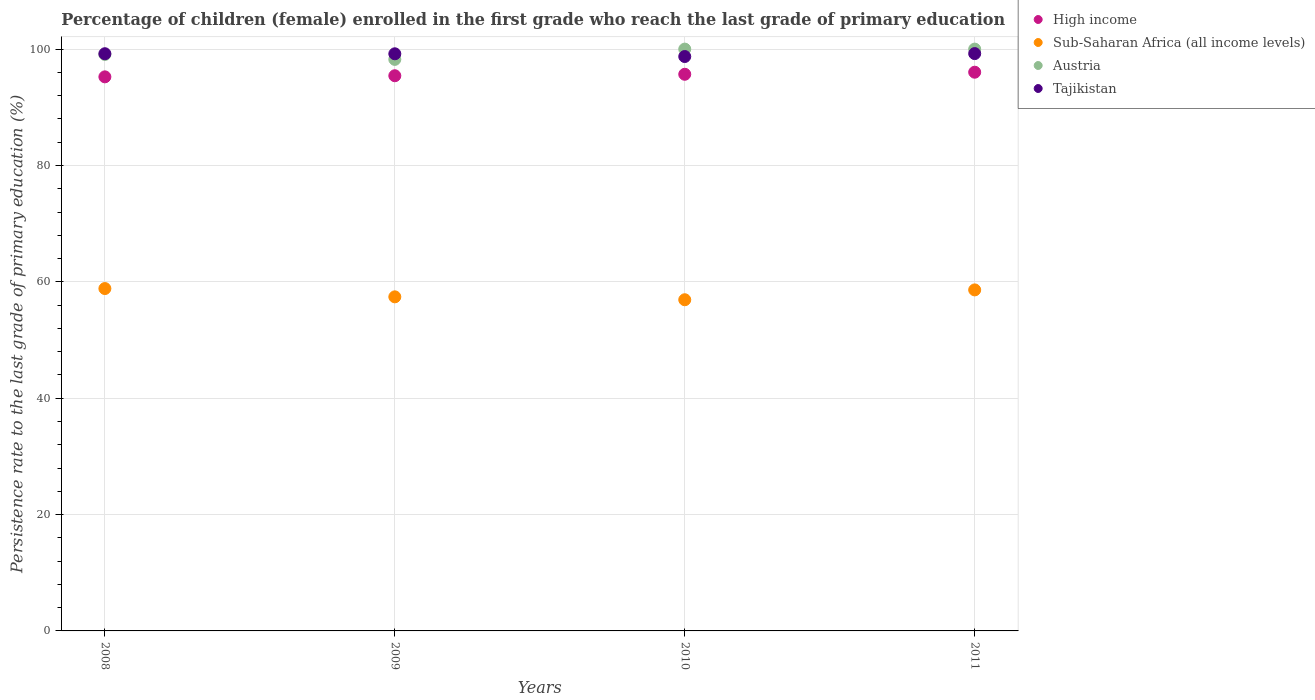What is the persistence rate of children in Tajikistan in 2010?
Make the answer very short. 98.72. Across all years, what is the maximum persistence rate of children in Austria?
Offer a very short reply. 100. Across all years, what is the minimum persistence rate of children in Austria?
Offer a terse response. 98.23. In which year was the persistence rate of children in Tajikistan maximum?
Your answer should be compact. 2011. In which year was the persistence rate of children in Tajikistan minimum?
Ensure brevity in your answer.  2010. What is the total persistence rate of children in High income in the graph?
Make the answer very short. 382.36. What is the difference between the persistence rate of children in High income in 2009 and that in 2011?
Keep it short and to the point. -0.61. What is the difference between the persistence rate of children in High income in 2009 and the persistence rate of children in Tajikistan in 2008?
Give a very brief answer. -3.78. What is the average persistence rate of children in Austria per year?
Ensure brevity in your answer.  99.33. In the year 2008, what is the difference between the persistence rate of children in Sub-Saharan Africa (all income levels) and persistence rate of children in High income?
Give a very brief answer. -36.39. In how many years, is the persistence rate of children in Sub-Saharan Africa (all income levels) greater than 52 %?
Ensure brevity in your answer.  4. What is the ratio of the persistence rate of children in Tajikistan in 2008 to that in 2009?
Provide a succinct answer. 1. Is the difference between the persistence rate of children in Sub-Saharan Africa (all income levels) in 2009 and 2010 greater than the difference between the persistence rate of children in High income in 2009 and 2010?
Make the answer very short. Yes. What is the difference between the highest and the second highest persistence rate of children in Tajikistan?
Ensure brevity in your answer.  0.02. What is the difference between the highest and the lowest persistence rate of children in Austria?
Your response must be concise. 1.77. In how many years, is the persistence rate of children in Sub-Saharan Africa (all income levels) greater than the average persistence rate of children in Sub-Saharan Africa (all income levels) taken over all years?
Ensure brevity in your answer.  2. Does the persistence rate of children in Tajikistan monotonically increase over the years?
Keep it short and to the point. No. Is the persistence rate of children in High income strictly greater than the persistence rate of children in Sub-Saharan Africa (all income levels) over the years?
Keep it short and to the point. Yes. How many dotlines are there?
Provide a succinct answer. 4. How many years are there in the graph?
Offer a terse response. 4. Does the graph contain grids?
Your answer should be compact. Yes. How are the legend labels stacked?
Your response must be concise. Vertical. What is the title of the graph?
Your response must be concise. Percentage of children (female) enrolled in the first grade who reach the last grade of primary education. What is the label or title of the X-axis?
Offer a very short reply. Years. What is the label or title of the Y-axis?
Keep it short and to the point. Persistence rate to the last grade of primary education (%). What is the Persistence rate to the last grade of primary education (%) in High income in 2008?
Give a very brief answer. 95.23. What is the Persistence rate to the last grade of primary education (%) in Sub-Saharan Africa (all income levels) in 2008?
Your response must be concise. 58.85. What is the Persistence rate to the last grade of primary education (%) in Austria in 2008?
Give a very brief answer. 99.08. What is the Persistence rate to the last grade of primary education (%) of Tajikistan in 2008?
Your answer should be compact. 99.21. What is the Persistence rate to the last grade of primary education (%) in High income in 2009?
Your response must be concise. 95.42. What is the Persistence rate to the last grade of primary education (%) of Sub-Saharan Africa (all income levels) in 2009?
Your answer should be very brief. 57.42. What is the Persistence rate to the last grade of primary education (%) of Austria in 2009?
Provide a succinct answer. 98.23. What is the Persistence rate to the last grade of primary education (%) of Tajikistan in 2009?
Provide a succinct answer. 99.19. What is the Persistence rate to the last grade of primary education (%) in High income in 2010?
Give a very brief answer. 95.67. What is the Persistence rate to the last grade of primary education (%) of Sub-Saharan Africa (all income levels) in 2010?
Your answer should be compact. 56.92. What is the Persistence rate to the last grade of primary education (%) of Austria in 2010?
Your answer should be very brief. 100. What is the Persistence rate to the last grade of primary education (%) of Tajikistan in 2010?
Provide a short and direct response. 98.72. What is the Persistence rate to the last grade of primary education (%) in High income in 2011?
Give a very brief answer. 96.03. What is the Persistence rate to the last grade of primary education (%) of Sub-Saharan Africa (all income levels) in 2011?
Offer a terse response. 58.61. What is the Persistence rate to the last grade of primary education (%) in Tajikistan in 2011?
Offer a very short reply. 99.23. Across all years, what is the maximum Persistence rate to the last grade of primary education (%) of High income?
Make the answer very short. 96.03. Across all years, what is the maximum Persistence rate to the last grade of primary education (%) in Sub-Saharan Africa (all income levels)?
Provide a short and direct response. 58.85. Across all years, what is the maximum Persistence rate to the last grade of primary education (%) in Austria?
Make the answer very short. 100. Across all years, what is the maximum Persistence rate to the last grade of primary education (%) of Tajikistan?
Ensure brevity in your answer.  99.23. Across all years, what is the minimum Persistence rate to the last grade of primary education (%) of High income?
Offer a terse response. 95.23. Across all years, what is the minimum Persistence rate to the last grade of primary education (%) of Sub-Saharan Africa (all income levels)?
Your answer should be very brief. 56.92. Across all years, what is the minimum Persistence rate to the last grade of primary education (%) of Austria?
Your answer should be very brief. 98.23. Across all years, what is the minimum Persistence rate to the last grade of primary education (%) in Tajikistan?
Provide a short and direct response. 98.72. What is the total Persistence rate to the last grade of primary education (%) of High income in the graph?
Your answer should be compact. 382.36. What is the total Persistence rate to the last grade of primary education (%) in Sub-Saharan Africa (all income levels) in the graph?
Make the answer very short. 231.8. What is the total Persistence rate to the last grade of primary education (%) of Austria in the graph?
Provide a short and direct response. 397.32. What is the total Persistence rate to the last grade of primary education (%) in Tajikistan in the graph?
Offer a terse response. 396.35. What is the difference between the Persistence rate to the last grade of primary education (%) in High income in 2008 and that in 2009?
Offer a very short reply. -0.19. What is the difference between the Persistence rate to the last grade of primary education (%) in Sub-Saharan Africa (all income levels) in 2008 and that in 2009?
Give a very brief answer. 1.43. What is the difference between the Persistence rate to the last grade of primary education (%) in Austria in 2008 and that in 2009?
Offer a terse response. 0.85. What is the difference between the Persistence rate to the last grade of primary education (%) in Tajikistan in 2008 and that in 2009?
Give a very brief answer. 0.01. What is the difference between the Persistence rate to the last grade of primary education (%) in High income in 2008 and that in 2010?
Give a very brief answer. -0.44. What is the difference between the Persistence rate to the last grade of primary education (%) in Sub-Saharan Africa (all income levels) in 2008 and that in 2010?
Keep it short and to the point. 1.92. What is the difference between the Persistence rate to the last grade of primary education (%) in Austria in 2008 and that in 2010?
Provide a succinct answer. -0.92. What is the difference between the Persistence rate to the last grade of primary education (%) of Tajikistan in 2008 and that in 2010?
Give a very brief answer. 0.48. What is the difference between the Persistence rate to the last grade of primary education (%) of High income in 2008 and that in 2011?
Your answer should be very brief. -0.8. What is the difference between the Persistence rate to the last grade of primary education (%) of Sub-Saharan Africa (all income levels) in 2008 and that in 2011?
Ensure brevity in your answer.  0.23. What is the difference between the Persistence rate to the last grade of primary education (%) of Austria in 2008 and that in 2011?
Offer a terse response. -0.92. What is the difference between the Persistence rate to the last grade of primary education (%) in Tajikistan in 2008 and that in 2011?
Make the answer very short. -0.02. What is the difference between the Persistence rate to the last grade of primary education (%) of High income in 2009 and that in 2010?
Keep it short and to the point. -0.25. What is the difference between the Persistence rate to the last grade of primary education (%) of Sub-Saharan Africa (all income levels) in 2009 and that in 2010?
Offer a terse response. 0.5. What is the difference between the Persistence rate to the last grade of primary education (%) of Austria in 2009 and that in 2010?
Your response must be concise. -1.77. What is the difference between the Persistence rate to the last grade of primary education (%) of Tajikistan in 2009 and that in 2010?
Offer a very short reply. 0.47. What is the difference between the Persistence rate to the last grade of primary education (%) of High income in 2009 and that in 2011?
Give a very brief answer. -0.61. What is the difference between the Persistence rate to the last grade of primary education (%) of Sub-Saharan Africa (all income levels) in 2009 and that in 2011?
Ensure brevity in your answer.  -1.19. What is the difference between the Persistence rate to the last grade of primary education (%) in Austria in 2009 and that in 2011?
Provide a succinct answer. -1.77. What is the difference between the Persistence rate to the last grade of primary education (%) of Tajikistan in 2009 and that in 2011?
Provide a succinct answer. -0.03. What is the difference between the Persistence rate to the last grade of primary education (%) of High income in 2010 and that in 2011?
Your answer should be very brief. -0.36. What is the difference between the Persistence rate to the last grade of primary education (%) of Sub-Saharan Africa (all income levels) in 2010 and that in 2011?
Give a very brief answer. -1.69. What is the difference between the Persistence rate to the last grade of primary education (%) of Tajikistan in 2010 and that in 2011?
Your answer should be very brief. -0.5. What is the difference between the Persistence rate to the last grade of primary education (%) in High income in 2008 and the Persistence rate to the last grade of primary education (%) in Sub-Saharan Africa (all income levels) in 2009?
Your response must be concise. 37.81. What is the difference between the Persistence rate to the last grade of primary education (%) of High income in 2008 and the Persistence rate to the last grade of primary education (%) of Austria in 2009?
Your answer should be compact. -3. What is the difference between the Persistence rate to the last grade of primary education (%) of High income in 2008 and the Persistence rate to the last grade of primary education (%) of Tajikistan in 2009?
Keep it short and to the point. -3.96. What is the difference between the Persistence rate to the last grade of primary education (%) in Sub-Saharan Africa (all income levels) in 2008 and the Persistence rate to the last grade of primary education (%) in Austria in 2009?
Offer a very short reply. -39.39. What is the difference between the Persistence rate to the last grade of primary education (%) of Sub-Saharan Africa (all income levels) in 2008 and the Persistence rate to the last grade of primary education (%) of Tajikistan in 2009?
Ensure brevity in your answer.  -40.35. What is the difference between the Persistence rate to the last grade of primary education (%) in Austria in 2008 and the Persistence rate to the last grade of primary education (%) in Tajikistan in 2009?
Give a very brief answer. -0.11. What is the difference between the Persistence rate to the last grade of primary education (%) in High income in 2008 and the Persistence rate to the last grade of primary education (%) in Sub-Saharan Africa (all income levels) in 2010?
Provide a short and direct response. 38.31. What is the difference between the Persistence rate to the last grade of primary education (%) of High income in 2008 and the Persistence rate to the last grade of primary education (%) of Austria in 2010?
Keep it short and to the point. -4.77. What is the difference between the Persistence rate to the last grade of primary education (%) in High income in 2008 and the Persistence rate to the last grade of primary education (%) in Tajikistan in 2010?
Give a very brief answer. -3.49. What is the difference between the Persistence rate to the last grade of primary education (%) of Sub-Saharan Africa (all income levels) in 2008 and the Persistence rate to the last grade of primary education (%) of Austria in 2010?
Make the answer very short. -41.15. What is the difference between the Persistence rate to the last grade of primary education (%) in Sub-Saharan Africa (all income levels) in 2008 and the Persistence rate to the last grade of primary education (%) in Tajikistan in 2010?
Offer a terse response. -39.88. What is the difference between the Persistence rate to the last grade of primary education (%) in Austria in 2008 and the Persistence rate to the last grade of primary education (%) in Tajikistan in 2010?
Give a very brief answer. 0.36. What is the difference between the Persistence rate to the last grade of primary education (%) of High income in 2008 and the Persistence rate to the last grade of primary education (%) of Sub-Saharan Africa (all income levels) in 2011?
Offer a very short reply. 36.62. What is the difference between the Persistence rate to the last grade of primary education (%) in High income in 2008 and the Persistence rate to the last grade of primary education (%) in Austria in 2011?
Ensure brevity in your answer.  -4.77. What is the difference between the Persistence rate to the last grade of primary education (%) of High income in 2008 and the Persistence rate to the last grade of primary education (%) of Tajikistan in 2011?
Ensure brevity in your answer.  -4. What is the difference between the Persistence rate to the last grade of primary education (%) in Sub-Saharan Africa (all income levels) in 2008 and the Persistence rate to the last grade of primary education (%) in Austria in 2011?
Provide a short and direct response. -41.15. What is the difference between the Persistence rate to the last grade of primary education (%) of Sub-Saharan Africa (all income levels) in 2008 and the Persistence rate to the last grade of primary education (%) of Tajikistan in 2011?
Offer a very short reply. -40.38. What is the difference between the Persistence rate to the last grade of primary education (%) in Austria in 2008 and the Persistence rate to the last grade of primary education (%) in Tajikistan in 2011?
Give a very brief answer. -0.15. What is the difference between the Persistence rate to the last grade of primary education (%) of High income in 2009 and the Persistence rate to the last grade of primary education (%) of Sub-Saharan Africa (all income levels) in 2010?
Offer a very short reply. 38.5. What is the difference between the Persistence rate to the last grade of primary education (%) of High income in 2009 and the Persistence rate to the last grade of primary education (%) of Austria in 2010?
Give a very brief answer. -4.58. What is the difference between the Persistence rate to the last grade of primary education (%) of High income in 2009 and the Persistence rate to the last grade of primary education (%) of Tajikistan in 2010?
Your response must be concise. -3.3. What is the difference between the Persistence rate to the last grade of primary education (%) of Sub-Saharan Africa (all income levels) in 2009 and the Persistence rate to the last grade of primary education (%) of Austria in 2010?
Give a very brief answer. -42.58. What is the difference between the Persistence rate to the last grade of primary education (%) of Sub-Saharan Africa (all income levels) in 2009 and the Persistence rate to the last grade of primary education (%) of Tajikistan in 2010?
Your response must be concise. -41.3. What is the difference between the Persistence rate to the last grade of primary education (%) in Austria in 2009 and the Persistence rate to the last grade of primary education (%) in Tajikistan in 2010?
Give a very brief answer. -0.49. What is the difference between the Persistence rate to the last grade of primary education (%) in High income in 2009 and the Persistence rate to the last grade of primary education (%) in Sub-Saharan Africa (all income levels) in 2011?
Your response must be concise. 36.81. What is the difference between the Persistence rate to the last grade of primary education (%) in High income in 2009 and the Persistence rate to the last grade of primary education (%) in Austria in 2011?
Give a very brief answer. -4.58. What is the difference between the Persistence rate to the last grade of primary education (%) in High income in 2009 and the Persistence rate to the last grade of primary education (%) in Tajikistan in 2011?
Offer a very short reply. -3.81. What is the difference between the Persistence rate to the last grade of primary education (%) in Sub-Saharan Africa (all income levels) in 2009 and the Persistence rate to the last grade of primary education (%) in Austria in 2011?
Keep it short and to the point. -42.58. What is the difference between the Persistence rate to the last grade of primary education (%) in Sub-Saharan Africa (all income levels) in 2009 and the Persistence rate to the last grade of primary education (%) in Tajikistan in 2011?
Keep it short and to the point. -41.81. What is the difference between the Persistence rate to the last grade of primary education (%) of Austria in 2009 and the Persistence rate to the last grade of primary education (%) of Tajikistan in 2011?
Offer a terse response. -1. What is the difference between the Persistence rate to the last grade of primary education (%) in High income in 2010 and the Persistence rate to the last grade of primary education (%) in Sub-Saharan Africa (all income levels) in 2011?
Ensure brevity in your answer.  37.06. What is the difference between the Persistence rate to the last grade of primary education (%) in High income in 2010 and the Persistence rate to the last grade of primary education (%) in Austria in 2011?
Provide a succinct answer. -4.33. What is the difference between the Persistence rate to the last grade of primary education (%) in High income in 2010 and the Persistence rate to the last grade of primary education (%) in Tajikistan in 2011?
Offer a terse response. -3.55. What is the difference between the Persistence rate to the last grade of primary education (%) in Sub-Saharan Africa (all income levels) in 2010 and the Persistence rate to the last grade of primary education (%) in Austria in 2011?
Your response must be concise. -43.08. What is the difference between the Persistence rate to the last grade of primary education (%) in Sub-Saharan Africa (all income levels) in 2010 and the Persistence rate to the last grade of primary education (%) in Tajikistan in 2011?
Your answer should be very brief. -42.31. What is the difference between the Persistence rate to the last grade of primary education (%) in Austria in 2010 and the Persistence rate to the last grade of primary education (%) in Tajikistan in 2011?
Make the answer very short. 0.77. What is the average Persistence rate to the last grade of primary education (%) of High income per year?
Your answer should be compact. 95.59. What is the average Persistence rate to the last grade of primary education (%) of Sub-Saharan Africa (all income levels) per year?
Provide a short and direct response. 57.95. What is the average Persistence rate to the last grade of primary education (%) in Austria per year?
Your answer should be compact. 99.33. What is the average Persistence rate to the last grade of primary education (%) of Tajikistan per year?
Offer a very short reply. 99.09. In the year 2008, what is the difference between the Persistence rate to the last grade of primary education (%) in High income and Persistence rate to the last grade of primary education (%) in Sub-Saharan Africa (all income levels)?
Provide a succinct answer. 36.39. In the year 2008, what is the difference between the Persistence rate to the last grade of primary education (%) of High income and Persistence rate to the last grade of primary education (%) of Austria?
Provide a short and direct response. -3.85. In the year 2008, what is the difference between the Persistence rate to the last grade of primary education (%) of High income and Persistence rate to the last grade of primary education (%) of Tajikistan?
Your response must be concise. -3.97. In the year 2008, what is the difference between the Persistence rate to the last grade of primary education (%) in Sub-Saharan Africa (all income levels) and Persistence rate to the last grade of primary education (%) in Austria?
Your answer should be compact. -40.24. In the year 2008, what is the difference between the Persistence rate to the last grade of primary education (%) of Sub-Saharan Africa (all income levels) and Persistence rate to the last grade of primary education (%) of Tajikistan?
Your answer should be compact. -40.36. In the year 2008, what is the difference between the Persistence rate to the last grade of primary education (%) in Austria and Persistence rate to the last grade of primary education (%) in Tajikistan?
Your response must be concise. -0.12. In the year 2009, what is the difference between the Persistence rate to the last grade of primary education (%) in High income and Persistence rate to the last grade of primary education (%) in Sub-Saharan Africa (all income levels)?
Provide a short and direct response. 38. In the year 2009, what is the difference between the Persistence rate to the last grade of primary education (%) in High income and Persistence rate to the last grade of primary education (%) in Austria?
Offer a terse response. -2.81. In the year 2009, what is the difference between the Persistence rate to the last grade of primary education (%) of High income and Persistence rate to the last grade of primary education (%) of Tajikistan?
Make the answer very short. -3.77. In the year 2009, what is the difference between the Persistence rate to the last grade of primary education (%) in Sub-Saharan Africa (all income levels) and Persistence rate to the last grade of primary education (%) in Austria?
Give a very brief answer. -40.81. In the year 2009, what is the difference between the Persistence rate to the last grade of primary education (%) of Sub-Saharan Africa (all income levels) and Persistence rate to the last grade of primary education (%) of Tajikistan?
Give a very brief answer. -41.77. In the year 2009, what is the difference between the Persistence rate to the last grade of primary education (%) of Austria and Persistence rate to the last grade of primary education (%) of Tajikistan?
Offer a very short reply. -0.96. In the year 2010, what is the difference between the Persistence rate to the last grade of primary education (%) of High income and Persistence rate to the last grade of primary education (%) of Sub-Saharan Africa (all income levels)?
Make the answer very short. 38.75. In the year 2010, what is the difference between the Persistence rate to the last grade of primary education (%) in High income and Persistence rate to the last grade of primary education (%) in Austria?
Provide a succinct answer. -4.33. In the year 2010, what is the difference between the Persistence rate to the last grade of primary education (%) of High income and Persistence rate to the last grade of primary education (%) of Tajikistan?
Give a very brief answer. -3.05. In the year 2010, what is the difference between the Persistence rate to the last grade of primary education (%) of Sub-Saharan Africa (all income levels) and Persistence rate to the last grade of primary education (%) of Austria?
Give a very brief answer. -43.08. In the year 2010, what is the difference between the Persistence rate to the last grade of primary education (%) of Sub-Saharan Africa (all income levels) and Persistence rate to the last grade of primary education (%) of Tajikistan?
Offer a very short reply. -41.8. In the year 2010, what is the difference between the Persistence rate to the last grade of primary education (%) of Austria and Persistence rate to the last grade of primary education (%) of Tajikistan?
Your answer should be very brief. 1.28. In the year 2011, what is the difference between the Persistence rate to the last grade of primary education (%) in High income and Persistence rate to the last grade of primary education (%) in Sub-Saharan Africa (all income levels)?
Your answer should be compact. 37.42. In the year 2011, what is the difference between the Persistence rate to the last grade of primary education (%) of High income and Persistence rate to the last grade of primary education (%) of Austria?
Your answer should be very brief. -3.97. In the year 2011, what is the difference between the Persistence rate to the last grade of primary education (%) of High income and Persistence rate to the last grade of primary education (%) of Tajikistan?
Your response must be concise. -3.2. In the year 2011, what is the difference between the Persistence rate to the last grade of primary education (%) of Sub-Saharan Africa (all income levels) and Persistence rate to the last grade of primary education (%) of Austria?
Keep it short and to the point. -41.39. In the year 2011, what is the difference between the Persistence rate to the last grade of primary education (%) in Sub-Saharan Africa (all income levels) and Persistence rate to the last grade of primary education (%) in Tajikistan?
Your response must be concise. -40.62. In the year 2011, what is the difference between the Persistence rate to the last grade of primary education (%) in Austria and Persistence rate to the last grade of primary education (%) in Tajikistan?
Your answer should be compact. 0.77. What is the ratio of the Persistence rate to the last grade of primary education (%) in High income in 2008 to that in 2009?
Ensure brevity in your answer.  1. What is the ratio of the Persistence rate to the last grade of primary education (%) of Sub-Saharan Africa (all income levels) in 2008 to that in 2009?
Offer a terse response. 1.02. What is the ratio of the Persistence rate to the last grade of primary education (%) in Austria in 2008 to that in 2009?
Offer a terse response. 1.01. What is the ratio of the Persistence rate to the last grade of primary education (%) in Tajikistan in 2008 to that in 2009?
Your response must be concise. 1. What is the ratio of the Persistence rate to the last grade of primary education (%) of High income in 2008 to that in 2010?
Your response must be concise. 1. What is the ratio of the Persistence rate to the last grade of primary education (%) in Sub-Saharan Africa (all income levels) in 2008 to that in 2010?
Offer a very short reply. 1.03. What is the ratio of the Persistence rate to the last grade of primary education (%) of Austria in 2008 to that in 2010?
Provide a succinct answer. 0.99. What is the ratio of the Persistence rate to the last grade of primary education (%) in Tajikistan in 2008 to that in 2010?
Keep it short and to the point. 1. What is the ratio of the Persistence rate to the last grade of primary education (%) of Sub-Saharan Africa (all income levels) in 2008 to that in 2011?
Provide a short and direct response. 1. What is the ratio of the Persistence rate to the last grade of primary education (%) of Austria in 2008 to that in 2011?
Give a very brief answer. 0.99. What is the ratio of the Persistence rate to the last grade of primary education (%) of Tajikistan in 2008 to that in 2011?
Provide a succinct answer. 1. What is the ratio of the Persistence rate to the last grade of primary education (%) of High income in 2009 to that in 2010?
Your response must be concise. 1. What is the ratio of the Persistence rate to the last grade of primary education (%) in Sub-Saharan Africa (all income levels) in 2009 to that in 2010?
Give a very brief answer. 1.01. What is the ratio of the Persistence rate to the last grade of primary education (%) in Austria in 2009 to that in 2010?
Offer a terse response. 0.98. What is the ratio of the Persistence rate to the last grade of primary education (%) in Tajikistan in 2009 to that in 2010?
Keep it short and to the point. 1. What is the ratio of the Persistence rate to the last grade of primary education (%) in High income in 2009 to that in 2011?
Your response must be concise. 0.99. What is the ratio of the Persistence rate to the last grade of primary education (%) in Sub-Saharan Africa (all income levels) in 2009 to that in 2011?
Provide a short and direct response. 0.98. What is the ratio of the Persistence rate to the last grade of primary education (%) in Austria in 2009 to that in 2011?
Offer a terse response. 0.98. What is the ratio of the Persistence rate to the last grade of primary education (%) in Sub-Saharan Africa (all income levels) in 2010 to that in 2011?
Your response must be concise. 0.97. What is the ratio of the Persistence rate to the last grade of primary education (%) in Austria in 2010 to that in 2011?
Your response must be concise. 1. What is the difference between the highest and the second highest Persistence rate to the last grade of primary education (%) in High income?
Provide a succinct answer. 0.36. What is the difference between the highest and the second highest Persistence rate to the last grade of primary education (%) in Sub-Saharan Africa (all income levels)?
Your answer should be very brief. 0.23. What is the difference between the highest and the second highest Persistence rate to the last grade of primary education (%) in Tajikistan?
Your response must be concise. 0.02. What is the difference between the highest and the lowest Persistence rate to the last grade of primary education (%) in High income?
Your answer should be very brief. 0.8. What is the difference between the highest and the lowest Persistence rate to the last grade of primary education (%) in Sub-Saharan Africa (all income levels)?
Make the answer very short. 1.92. What is the difference between the highest and the lowest Persistence rate to the last grade of primary education (%) in Austria?
Make the answer very short. 1.77. What is the difference between the highest and the lowest Persistence rate to the last grade of primary education (%) of Tajikistan?
Your answer should be very brief. 0.5. 